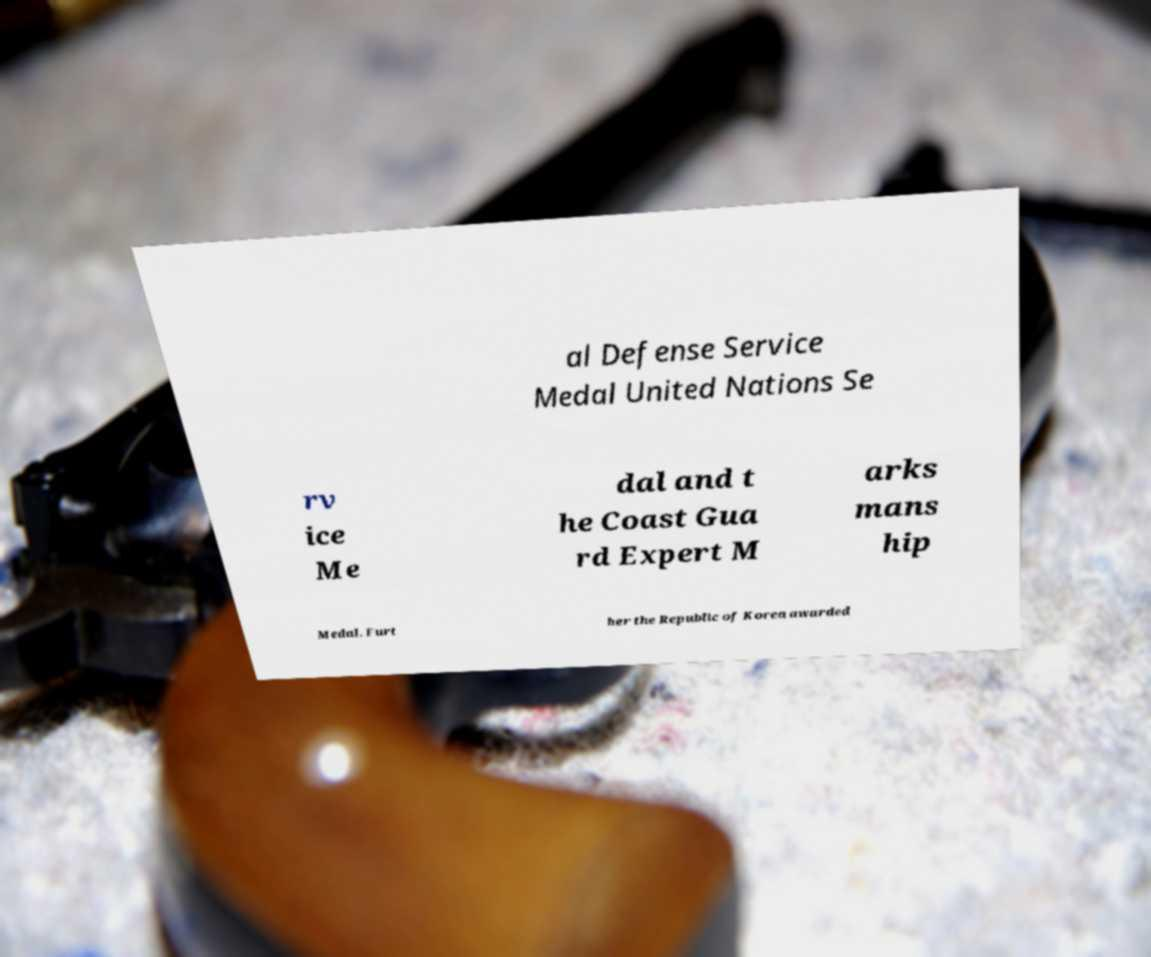For documentation purposes, I need the text within this image transcribed. Could you provide that? al Defense Service Medal United Nations Se rv ice Me dal and t he Coast Gua rd Expert M arks mans hip Medal. Furt her the Republic of Korea awarded 